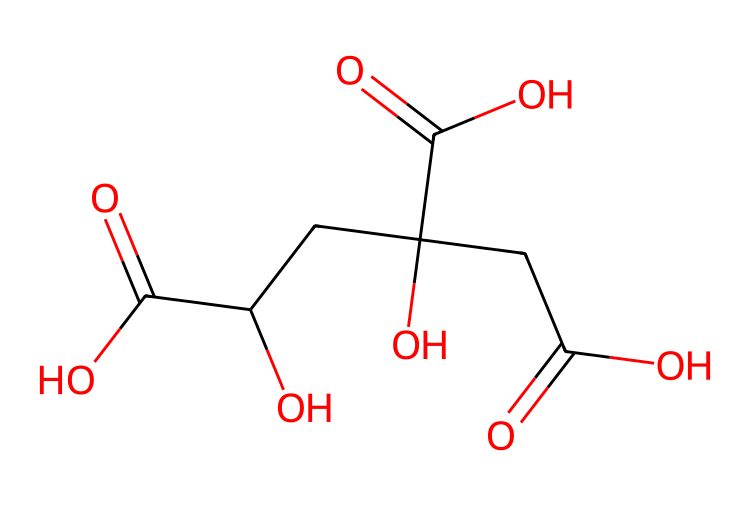What is the main functional group present in citric acid? The main functional group in citric acid is the carboxyl group, which can be identified by the presence of -COOH throughout the molecular structure.
Answer: carboxyl group How many carboxyl groups are in the citric acid molecule? The molecule contains three -COOH (carboxyl) groups, which can be counted directly from the structure.
Answer: three What is the total number of carbon atoms in citric acid? By analyzing the molecular structure, there are six carbon atoms present in the citric acid structure.
Answer: six Does citric acid have any hydroxyl (-OH) groups? Yes, citric acid contains one hydroxyl group, identifiable in the structure as an -OH connected to a carbon atom.
Answer: one What type of acid is citric acid classified as? Citric acid is classified as a weak organic acid due to its ability to partially dissociate in solution and its organic molecular structure.
Answer: weak organic acid How many total oxygen atoms are present in citric acid? The structure shows a total of eight oxygen atoms when counted in carboxyl and hydroxyl groups.
Answer: eight What impact does the presence of multiple carboxyl groups have on the acidity of citric acid? The presence of three carboxyl groups allows citric acid to donate multiple protons (H+ ions), which increases its acidity compared to monocarboxylic acids.
Answer: increases acidity 